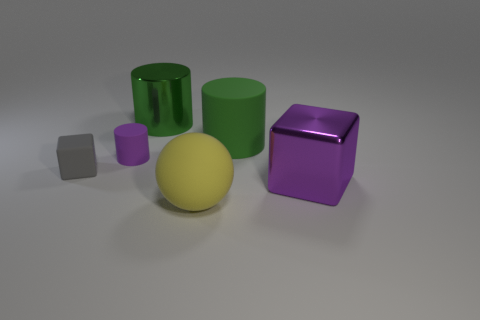Subtract all green cylinders. How many were subtracted if there are1green cylinders left? 1 Add 1 purple things. How many objects exist? 7 Subtract all cubes. How many objects are left? 4 Subtract 0 yellow blocks. How many objects are left? 6 Subtract all tiny brown metallic cylinders. Subtract all green shiny objects. How many objects are left? 5 Add 4 matte balls. How many matte balls are left? 5 Add 6 big rubber things. How many big rubber things exist? 8 